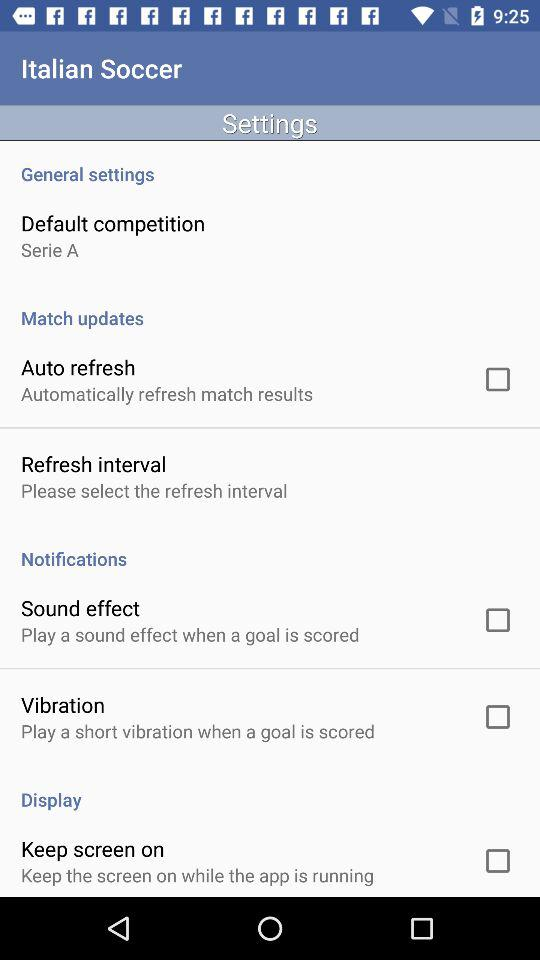What is the current status of the "Sound effect"? The status is "off". 